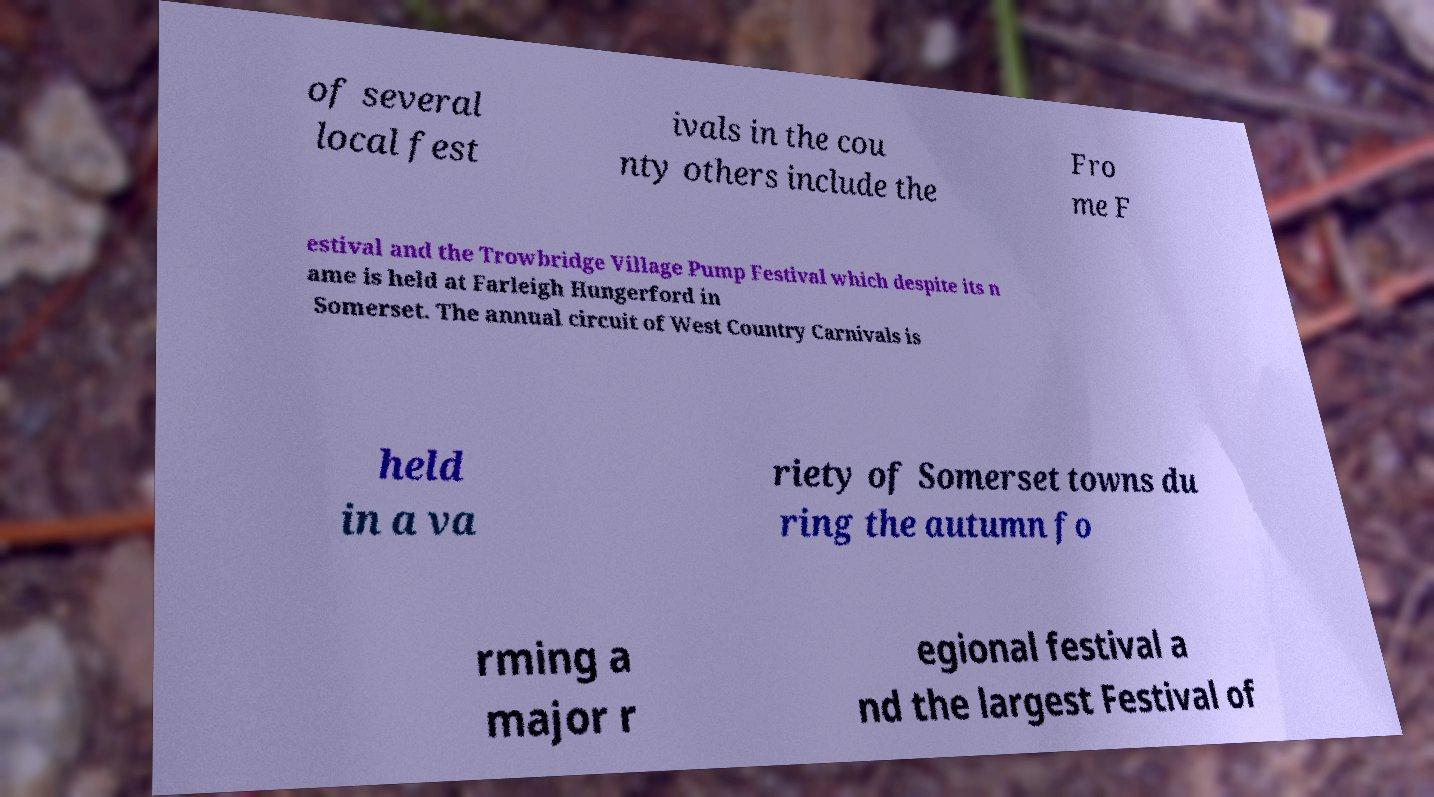I need the written content from this picture converted into text. Can you do that? of several local fest ivals in the cou nty others include the Fro me F estival and the Trowbridge Village Pump Festival which despite its n ame is held at Farleigh Hungerford in Somerset. The annual circuit of West Country Carnivals is held in a va riety of Somerset towns du ring the autumn fo rming a major r egional festival a nd the largest Festival of 